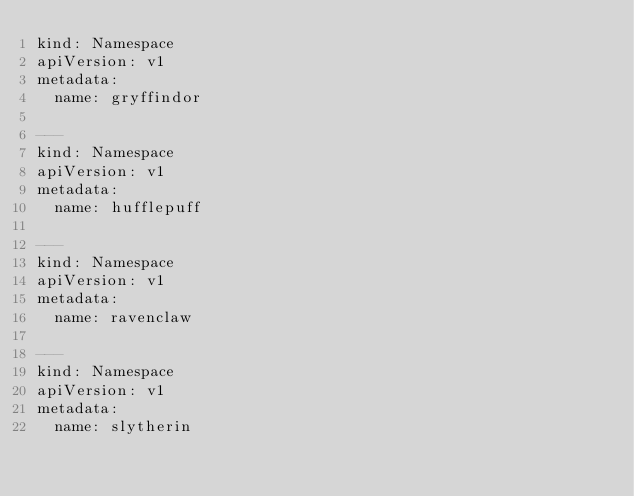Convert code to text. <code><loc_0><loc_0><loc_500><loc_500><_YAML_>kind: Namespace
apiVersion: v1
metadata:
  name: gryffindor

---
kind: Namespace
apiVersion: v1
metadata:
  name: hufflepuff

---
kind: Namespace
apiVersion: v1
metadata:
  name: ravenclaw

---
kind: Namespace
apiVersion: v1
metadata:
  name: slytherin
</code> 